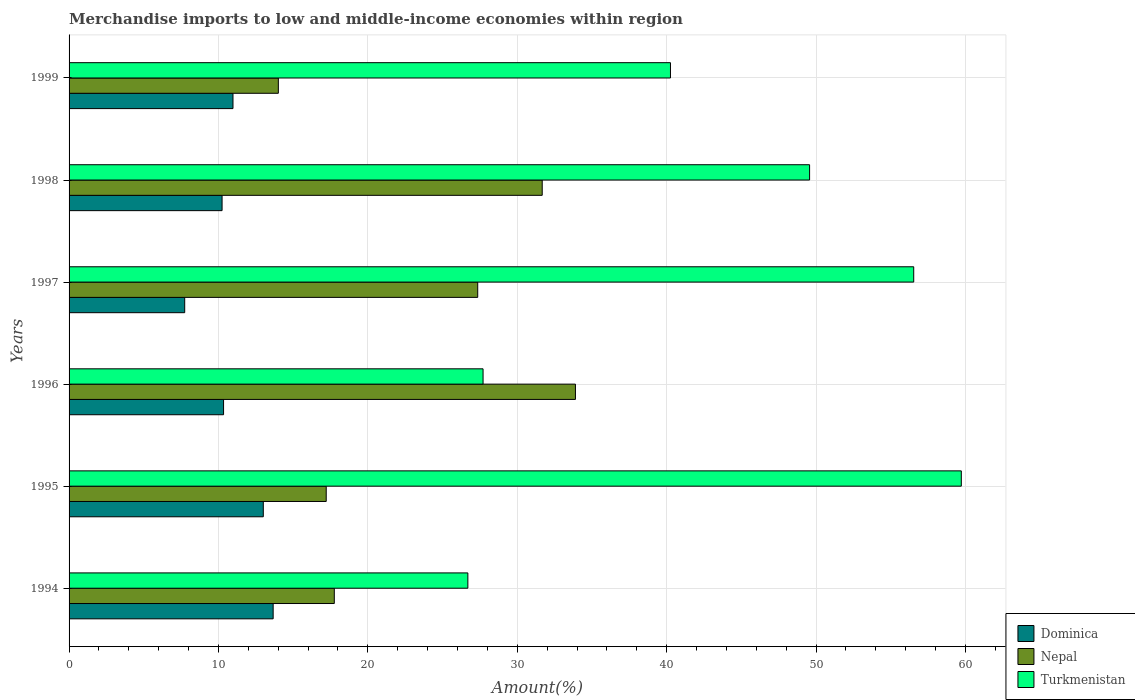How many different coloured bars are there?
Make the answer very short. 3. How many groups of bars are there?
Ensure brevity in your answer.  6. Are the number of bars per tick equal to the number of legend labels?
Your answer should be compact. Yes. How many bars are there on the 4th tick from the top?
Make the answer very short. 3. How many bars are there on the 5th tick from the bottom?
Your response must be concise. 3. What is the label of the 4th group of bars from the top?
Your response must be concise. 1996. What is the percentage of amount earned from merchandise imports in Dominica in 1998?
Give a very brief answer. 10.24. Across all years, what is the maximum percentage of amount earned from merchandise imports in Dominica?
Your answer should be compact. 13.66. Across all years, what is the minimum percentage of amount earned from merchandise imports in Turkmenistan?
Offer a very short reply. 26.69. In which year was the percentage of amount earned from merchandise imports in Turkmenistan maximum?
Your answer should be compact. 1995. In which year was the percentage of amount earned from merchandise imports in Nepal minimum?
Offer a very short reply. 1999. What is the total percentage of amount earned from merchandise imports in Turkmenistan in the graph?
Make the answer very short. 260.49. What is the difference between the percentage of amount earned from merchandise imports in Dominica in 1994 and that in 1998?
Your answer should be compact. 3.42. What is the difference between the percentage of amount earned from merchandise imports in Nepal in 1997 and the percentage of amount earned from merchandise imports in Turkmenistan in 1998?
Your answer should be compact. -22.22. What is the average percentage of amount earned from merchandise imports in Dominica per year?
Your answer should be very brief. 10.99. In the year 1997, what is the difference between the percentage of amount earned from merchandise imports in Dominica and percentage of amount earned from merchandise imports in Nepal?
Provide a succinct answer. -19.61. What is the ratio of the percentage of amount earned from merchandise imports in Dominica in 1995 to that in 1996?
Provide a short and direct response. 1.26. Is the percentage of amount earned from merchandise imports in Dominica in 1997 less than that in 1998?
Ensure brevity in your answer.  Yes. What is the difference between the highest and the second highest percentage of amount earned from merchandise imports in Dominica?
Provide a succinct answer. 0.66. What is the difference between the highest and the lowest percentage of amount earned from merchandise imports in Nepal?
Your response must be concise. 19.89. Is the sum of the percentage of amount earned from merchandise imports in Turkmenistan in 1994 and 1995 greater than the maximum percentage of amount earned from merchandise imports in Nepal across all years?
Offer a terse response. Yes. What does the 2nd bar from the top in 1998 represents?
Give a very brief answer. Nepal. What does the 1st bar from the bottom in 1994 represents?
Your answer should be compact. Dominica. Is it the case that in every year, the sum of the percentage of amount earned from merchandise imports in Turkmenistan and percentage of amount earned from merchandise imports in Dominica is greater than the percentage of amount earned from merchandise imports in Nepal?
Keep it short and to the point. Yes. How many bars are there?
Your response must be concise. 18. Does the graph contain any zero values?
Make the answer very short. No. Where does the legend appear in the graph?
Provide a succinct answer. Bottom right. How many legend labels are there?
Provide a succinct answer. 3. How are the legend labels stacked?
Provide a short and direct response. Vertical. What is the title of the graph?
Make the answer very short. Merchandise imports to low and middle-income economies within region. What is the label or title of the X-axis?
Give a very brief answer. Amount(%). What is the label or title of the Y-axis?
Give a very brief answer. Years. What is the Amount(%) of Dominica in 1994?
Ensure brevity in your answer.  13.66. What is the Amount(%) in Nepal in 1994?
Your response must be concise. 17.75. What is the Amount(%) of Turkmenistan in 1994?
Offer a very short reply. 26.69. What is the Amount(%) of Dominica in 1995?
Make the answer very short. 13. What is the Amount(%) in Nepal in 1995?
Provide a short and direct response. 17.21. What is the Amount(%) of Turkmenistan in 1995?
Your answer should be very brief. 59.72. What is the Amount(%) of Dominica in 1996?
Provide a short and direct response. 10.34. What is the Amount(%) in Nepal in 1996?
Your answer should be compact. 33.89. What is the Amount(%) of Turkmenistan in 1996?
Offer a terse response. 27.71. What is the Amount(%) in Dominica in 1997?
Keep it short and to the point. 7.74. What is the Amount(%) of Nepal in 1997?
Provide a short and direct response. 27.35. What is the Amount(%) of Turkmenistan in 1997?
Provide a short and direct response. 56.54. What is the Amount(%) in Dominica in 1998?
Offer a very short reply. 10.24. What is the Amount(%) of Nepal in 1998?
Your response must be concise. 31.67. What is the Amount(%) in Turkmenistan in 1998?
Give a very brief answer. 49.57. What is the Amount(%) in Dominica in 1999?
Give a very brief answer. 10.97. What is the Amount(%) of Nepal in 1999?
Your response must be concise. 14.01. What is the Amount(%) of Turkmenistan in 1999?
Keep it short and to the point. 40.26. Across all years, what is the maximum Amount(%) in Dominica?
Provide a succinct answer. 13.66. Across all years, what is the maximum Amount(%) of Nepal?
Ensure brevity in your answer.  33.89. Across all years, what is the maximum Amount(%) of Turkmenistan?
Ensure brevity in your answer.  59.72. Across all years, what is the minimum Amount(%) in Dominica?
Your answer should be very brief. 7.74. Across all years, what is the minimum Amount(%) of Nepal?
Your response must be concise. 14.01. Across all years, what is the minimum Amount(%) of Turkmenistan?
Offer a terse response. 26.69. What is the total Amount(%) in Dominica in the graph?
Give a very brief answer. 65.96. What is the total Amount(%) of Nepal in the graph?
Your response must be concise. 141.89. What is the total Amount(%) in Turkmenistan in the graph?
Offer a terse response. 260.49. What is the difference between the Amount(%) of Dominica in 1994 and that in 1995?
Make the answer very short. 0.66. What is the difference between the Amount(%) in Nepal in 1994 and that in 1995?
Make the answer very short. 0.54. What is the difference between the Amount(%) in Turkmenistan in 1994 and that in 1995?
Offer a very short reply. -33.03. What is the difference between the Amount(%) in Dominica in 1994 and that in 1996?
Your response must be concise. 3.32. What is the difference between the Amount(%) in Nepal in 1994 and that in 1996?
Provide a succinct answer. -16.14. What is the difference between the Amount(%) of Turkmenistan in 1994 and that in 1996?
Offer a very short reply. -1.02. What is the difference between the Amount(%) in Dominica in 1994 and that in 1997?
Your answer should be compact. 5.92. What is the difference between the Amount(%) of Nepal in 1994 and that in 1997?
Provide a short and direct response. -9.6. What is the difference between the Amount(%) in Turkmenistan in 1994 and that in 1997?
Ensure brevity in your answer.  -29.84. What is the difference between the Amount(%) in Dominica in 1994 and that in 1998?
Give a very brief answer. 3.42. What is the difference between the Amount(%) in Nepal in 1994 and that in 1998?
Offer a terse response. -13.92. What is the difference between the Amount(%) in Turkmenistan in 1994 and that in 1998?
Make the answer very short. -22.87. What is the difference between the Amount(%) of Dominica in 1994 and that in 1999?
Offer a terse response. 2.69. What is the difference between the Amount(%) in Nepal in 1994 and that in 1999?
Offer a very short reply. 3.75. What is the difference between the Amount(%) in Turkmenistan in 1994 and that in 1999?
Ensure brevity in your answer.  -13.56. What is the difference between the Amount(%) of Dominica in 1995 and that in 1996?
Your answer should be very brief. 2.66. What is the difference between the Amount(%) of Nepal in 1995 and that in 1996?
Your answer should be compact. -16.68. What is the difference between the Amount(%) in Turkmenistan in 1995 and that in 1996?
Provide a succinct answer. 32.01. What is the difference between the Amount(%) of Dominica in 1995 and that in 1997?
Make the answer very short. 5.26. What is the difference between the Amount(%) of Nepal in 1995 and that in 1997?
Your response must be concise. -10.14. What is the difference between the Amount(%) in Turkmenistan in 1995 and that in 1997?
Offer a terse response. 3.19. What is the difference between the Amount(%) in Dominica in 1995 and that in 1998?
Offer a terse response. 2.76. What is the difference between the Amount(%) in Nepal in 1995 and that in 1998?
Give a very brief answer. -14.46. What is the difference between the Amount(%) of Turkmenistan in 1995 and that in 1998?
Your answer should be compact. 10.16. What is the difference between the Amount(%) in Dominica in 1995 and that in 1999?
Make the answer very short. 2.03. What is the difference between the Amount(%) in Nepal in 1995 and that in 1999?
Your answer should be very brief. 3.2. What is the difference between the Amount(%) in Turkmenistan in 1995 and that in 1999?
Offer a terse response. 19.47. What is the difference between the Amount(%) of Dominica in 1996 and that in 1997?
Provide a succinct answer. 2.6. What is the difference between the Amount(%) in Nepal in 1996 and that in 1997?
Make the answer very short. 6.54. What is the difference between the Amount(%) of Turkmenistan in 1996 and that in 1997?
Make the answer very short. -28.83. What is the difference between the Amount(%) in Dominica in 1996 and that in 1998?
Provide a succinct answer. 0.1. What is the difference between the Amount(%) of Nepal in 1996 and that in 1998?
Keep it short and to the point. 2.22. What is the difference between the Amount(%) in Turkmenistan in 1996 and that in 1998?
Your response must be concise. -21.86. What is the difference between the Amount(%) in Dominica in 1996 and that in 1999?
Your answer should be compact. -0.63. What is the difference between the Amount(%) of Nepal in 1996 and that in 1999?
Offer a terse response. 19.89. What is the difference between the Amount(%) in Turkmenistan in 1996 and that in 1999?
Ensure brevity in your answer.  -12.54. What is the difference between the Amount(%) in Dominica in 1997 and that in 1998?
Your response must be concise. -2.5. What is the difference between the Amount(%) of Nepal in 1997 and that in 1998?
Provide a short and direct response. -4.32. What is the difference between the Amount(%) in Turkmenistan in 1997 and that in 1998?
Keep it short and to the point. 6.97. What is the difference between the Amount(%) of Dominica in 1997 and that in 1999?
Your answer should be compact. -3.23. What is the difference between the Amount(%) of Nepal in 1997 and that in 1999?
Your answer should be very brief. 13.34. What is the difference between the Amount(%) in Turkmenistan in 1997 and that in 1999?
Your answer should be very brief. 16.28. What is the difference between the Amount(%) in Dominica in 1998 and that in 1999?
Make the answer very short. -0.73. What is the difference between the Amount(%) of Nepal in 1998 and that in 1999?
Give a very brief answer. 17.66. What is the difference between the Amount(%) in Turkmenistan in 1998 and that in 1999?
Give a very brief answer. 9.31. What is the difference between the Amount(%) in Dominica in 1994 and the Amount(%) in Nepal in 1995?
Provide a short and direct response. -3.55. What is the difference between the Amount(%) of Dominica in 1994 and the Amount(%) of Turkmenistan in 1995?
Your answer should be very brief. -46.06. What is the difference between the Amount(%) of Nepal in 1994 and the Amount(%) of Turkmenistan in 1995?
Provide a succinct answer. -41.97. What is the difference between the Amount(%) of Dominica in 1994 and the Amount(%) of Nepal in 1996?
Provide a short and direct response. -20.23. What is the difference between the Amount(%) in Dominica in 1994 and the Amount(%) in Turkmenistan in 1996?
Offer a very short reply. -14.05. What is the difference between the Amount(%) in Nepal in 1994 and the Amount(%) in Turkmenistan in 1996?
Make the answer very short. -9.96. What is the difference between the Amount(%) in Dominica in 1994 and the Amount(%) in Nepal in 1997?
Your answer should be compact. -13.69. What is the difference between the Amount(%) of Dominica in 1994 and the Amount(%) of Turkmenistan in 1997?
Offer a terse response. -42.88. What is the difference between the Amount(%) in Nepal in 1994 and the Amount(%) in Turkmenistan in 1997?
Your response must be concise. -38.78. What is the difference between the Amount(%) in Dominica in 1994 and the Amount(%) in Nepal in 1998?
Give a very brief answer. -18.01. What is the difference between the Amount(%) of Dominica in 1994 and the Amount(%) of Turkmenistan in 1998?
Offer a terse response. -35.91. What is the difference between the Amount(%) of Nepal in 1994 and the Amount(%) of Turkmenistan in 1998?
Your answer should be compact. -31.81. What is the difference between the Amount(%) in Dominica in 1994 and the Amount(%) in Nepal in 1999?
Your answer should be very brief. -0.35. What is the difference between the Amount(%) in Dominica in 1994 and the Amount(%) in Turkmenistan in 1999?
Keep it short and to the point. -26.59. What is the difference between the Amount(%) of Nepal in 1994 and the Amount(%) of Turkmenistan in 1999?
Your answer should be very brief. -22.5. What is the difference between the Amount(%) in Dominica in 1995 and the Amount(%) in Nepal in 1996?
Your answer should be very brief. -20.89. What is the difference between the Amount(%) of Dominica in 1995 and the Amount(%) of Turkmenistan in 1996?
Offer a very short reply. -14.71. What is the difference between the Amount(%) of Nepal in 1995 and the Amount(%) of Turkmenistan in 1996?
Offer a terse response. -10.5. What is the difference between the Amount(%) in Dominica in 1995 and the Amount(%) in Nepal in 1997?
Make the answer very short. -14.35. What is the difference between the Amount(%) in Dominica in 1995 and the Amount(%) in Turkmenistan in 1997?
Give a very brief answer. -43.54. What is the difference between the Amount(%) in Nepal in 1995 and the Amount(%) in Turkmenistan in 1997?
Provide a short and direct response. -39.32. What is the difference between the Amount(%) of Dominica in 1995 and the Amount(%) of Nepal in 1998?
Ensure brevity in your answer.  -18.67. What is the difference between the Amount(%) of Dominica in 1995 and the Amount(%) of Turkmenistan in 1998?
Offer a terse response. -36.57. What is the difference between the Amount(%) of Nepal in 1995 and the Amount(%) of Turkmenistan in 1998?
Make the answer very short. -32.36. What is the difference between the Amount(%) in Dominica in 1995 and the Amount(%) in Nepal in 1999?
Offer a very short reply. -1.01. What is the difference between the Amount(%) in Dominica in 1995 and the Amount(%) in Turkmenistan in 1999?
Ensure brevity in your answer.  -27.25. What is the difference between the Amount(%) of Nepal in 1995 and the Amount(%) of Turkmenistan in 1999?
Ensure brevity in your answer.  -23.04. What is the difference between the Amount(%) of Dominica in 1996 and the Amount(%) of Nepal in 1997?
Provide a short and direct response. -17.01. What is the difference between the Amount(%) in Dominica in 1996 and the Amount(%) in Turkmenistan in 1997?
Your answer should be very brief. -46.2. What is the difference between the Amount(%) in Nepal in 1996 and the Amount(%) in Turkmenistan in 1997?
Provide a short and direct response. -22.64. What is the difference between the Amount(%) of Dominica in 1996 and the Amount(%) of Nepal in 1998?
Your answer should be very brief. -21.33. What is the difference between the Amount(%) in Dominica in 1996 and the Amount(%) in Turkmenistan in 1998?
Your answer should be very brief. -39.23. What is the difference between the Amount(%) in Nepal in 1996 and the Amount(%) in Turkmenistan in 1998?
Your answer should be compact. -15.67. What is the difference between the Amount(%) of Dominica in 1996 and the Amount(%) of Nepal in 1999?
Give a very brief answer. -3.67. What is the difference between the Amount(%) in Dominica in 1996 and the Amount(%) in Turkmenistan in 1999?
Ensure brevity in your answer.  -29.91. What is the difference between the Amount(%) in Nepal in 1996 and the Amount(%) in Turkmenistan in 1999?
Provide a short and direct response. -6.36. What is the difference between the Amount(%) of Dominica in 1997 and the Amount(%) of Nepal in 1998?
Your response must be concise. -23.93. What is the difference between the Amount(%) of Dominica in 1997 and the Amount(%) of Turkmenistan in 1998?
Your answer should be compact. -41.83. What is the difference between the Amount(%) of Nepal in 1997 and the Amount(%) of Turkmenistan in 1998?
Your response must be concise. -22.22. What is the difference between the Amount(%) in Dominica in 1997 and the Amount(%) in Nepal in 1999?
Keep it short and to the point. -6.27. What is the difference between the Amount(%) in Dominica in 1997 and the Amount(%) in Turkmenistan in 1999?
Offer a very short reply. -32.52. What is the difference between the Amount(%) of Nepal in 1997 and the Amount(%) of Turkmenistan in 1999?
Your answer should be compact. -12.9. What is the difference between the Amount(%) in Dominica in 1998 and the Amount(%) in Nepal in 1999?
Provide a succinct answer. -3.77. What is the difference between the Amount(%) in Dominica in 1998 and the Amount(%) in Turkmenistan in 1999?
Provide a short and direct response. -30.01. What is the difference between the Amount(%) in Nepal in 1998 and the Amount(%) in Turkmenistan in 1999?
Make the answer very short. -8.59. What is the average Amount(%) of Dominica per year?
Offer a very short reply. 10.99. What is the average Amount(%) in Nepal per year?
Provide a short and direct response. 23.65. What is the average Amount(%) in Turkmenistan per year?
Provide a succinct answer. 43.41. In the year 1994, what is the difference between the Amount(%) of Dominica and Amount(%) of Nepal?
Your response must be concise. -4.09. In the year 1994, what is the difference between the Amount(%) of Dominica and Amount(%) of Turkmenistan?
Ensure brevity in your answer.  -13.03. In the year 1994, what is the difference between the Amount(%) in Nepal and Amount(%) in Turkmenistan?
Ensure brevity in your answer.  -8.94. In the year 1995, what is the difference between the Amount(%) of Dominica and Amount(%) of Nepal?
Provide a short and direct response. -4.21. In the year 1995, what is the difference between the Amount(%) of Dominica and Amount(%) of Turkmenistan?
Provide a short and direct response. -46.72. In the year 1995, what is the difference between the Amount(%) in Nepal and Amount(%) in Turkmenistan?
Give a very brief answer. -42.51. In the year 1996, what is the difference between the Amount(%) in Dominica and Amount(%) in Nepal?
Your response must be concise. -23.55. In the year 1996, what is the difference between the Amount(%) in Dominica and Amount(%) in Turkmenistan?
Your answer should be compact. -17.37. In the year 1996, what is the difference between the Amount(%) of Nepal and Amount(%) of Turkmenistan?
Provide a succinct answer. 6.18. In the year 1997, what is the difference between the Amount(%) of Dominica and Amount(%) of Nepal?
Your answer should be very brief. -19.61. In the year 1997, what is the difference between the Amount(%) in Dominica and Amount(%) in Turkmenistan?
Give a very brief answer. -48.8. In the year 1997, what is the difference between the Amount(%) in Nepal and Amount(%) in Turkmenistan?
Your answer should be very brief. -29.18. In the year 1998, what is the difference between the Amount(%) in Dominica and Amount(%) in Nepal?
Ensure brevity in your answer.  -21.43. In the year 1998, what is the difference between the Amount(%) in Dominica and Amount(%) in Turkmenistan?
Ensure brevity in your answer.  -39.33. In the year 1998, what is the difference between the Amount(%) in Nepal and Amount(%) in Turkmenistan?
Ensure brevity in your answer.  -17.9. In the year 1999, what is the difference between the Amount(%) in Dominica and Amount(%) in Nepal?
Your response must be concise. -3.04. In the year 1999, what is the difference between the Amount(%) of Dominica and Amount(%) of Turkmenistan?
Your answer should be very brief. -29.28. In the year 1999, what is the difference between the Amount(%) of Nepal and Amount(%) of Turkmenistan?
Keep it short and to the point. -26.25. What is the ratio of the Amount(%) of Dominica in 1994 to that in 1995?
Provide a short and direct response. 1.05. What is the ratio of the Amount(%) in Nepal in 1994 to that in 1995?
Offer a very short reply. 1.03. What is the ratio of the Amount(%) of Turkmenistan in 1994 to that in 1995?
Your answer should be compact. 0.45. What is the ratio of the Amount(%) of Dominica in 1994 to that in 1996?
Provide a short and direct response. 1.32. What is the ratio of the Amount(%) in Nepal in 1994 to that in 1996?
Your answer should be compact. 0.52. What is the ratio of the Amount(%) of Turkmenistan in 1994 to that in 1996?
Your answer should be very brief. 0.96. What is the ratio of the Amount(%) in Dominica in 1994 to that in 1997?
Make the answer very short. 1.76. What is the ratio of the Amount(%) of Nepal in 1994 to that in 1997?
Your answer should be very brief. 0.65. What is the ratio of the Amount(%) of Turkmenistan in 1994 to that in 1997?
Your answer should be very brief. 0.47. What is the ratio of the Amount(%) in Dominica in 1994 to that in 1998?
Offer a terse response. 1.33. What is the ratio of the Amount(%) of Nepal in 1994 to that in 1998?
Your answer should be very brief. 0.56. What is the ratio of the Amount(%) of Turkmenistan in 1994 to that in 1998?
Ensure brevity in your answer.  0.54. What is the ratio of the Amount(%) in Dominica in 1994 to that in 1999?
Provide a short and direct response. 1.25. What is the ratio of the Amount(%) in Nepal in 1994 to that in 1999?
Keep it short and to the point. 1.27. What is the ratio of the Amount(%) in Turkmenistan in 1994 to that in 1999?
Offer a terse response. 0.66. What is the ratio of the Amount(%) in Dominica in 1995 to that in 1996?
Keep it short and to the point. 1.26. What is the ratio of the Amount(%) in Nepal in 1995 to that in 1996?
Give a very brief answer. 0.51. What is the ratio of the Amount(%) of Turkmenistan in 1995 to that in 1996?
Ensure brevity in your answer.  2.16. What is the ratio of the Amount(%) in Dominica in 1995 to that in 1997?
Give a very brief answer. 1.68. What is the ratio of the Amount(%) of Nepal in 1995 to that in 1997?
Provide a succinct answer. 0.63. What is the ratio of the Amount(%) in Turkmenistan in 1995 to that in 1997?
Offer a very short reply. 1.06. What is the ratio of the Amount(%) of Dominica in 1995 to that in 1998?
Offer a very short reply. 1.27. What is the ratio of the Amount(%) in Nepal in 1995 to that in 1998?
Your answer should be compact. 0.54. What is the ratio of the Amount(%) in Turkmenistan in 1995 to that in 1998?
Make the answer very short. 1.2. What is the ratio of the Amount(%) of Dominica in 1995 to that in 1999?
Offer a very short reply. 1.19. What is the ratio of the Amount(%) in Nepal in 1995 to that in 1999?
Offer a terse response. 1.23. What is the ratio of the Amount(%) of Turkmenistan in 1995 to that in 1999?
Keep it short and to the point. 1.48. What is the ratio of the Amount(%) in Dominica in 1996 to that in 1997?
Your answer should be compact. 1.34. What is the ratio of the Amount(%) in Nepal in 1996 to that in 1997?
Keep it short and to the point. 1.24. What is the ratio of the Amount(%) of Turkmenistan in 1996 to that in 1997?
Ensure brevity in your answer.  0.49. What is the ratio of the Amount(%) of Dominica in 1996 to that in 1998?
Your answer should be very brief. 1.01. What is the ratio of the Amount(%) of Nepal in 1996 to that in 1998?
Ensure brevity in your answer.  1.07. What is the ratio of the Amount(%) of Turkmenistan in 1996 to that in 1998?
Offer a terse response. 0.56. What is the ratio of the Amount(%) of Dominica in 1996 to that in 1999?
Give a very brief answer. 0.94. What is the ratio of the Amount(%) in Nepal in 1996 to that in 1999?
Provide a succinct answer. 2.42. What is the ratio of the Amount(%) of Turkmenistan in 1996 to that in 1999?
Keep it short and to the point. 0.69. What is the ratio of the Amount(%) in Dominica in 1997 to that in 1998?
Ensure brevity in your answer.  0.76. What is the ratio of the Amount(%) in Nepal in 1997 to that in 1998?
Keep it short and to the point. 0.86. What is the ratio of the Amount(%) of Turkmenistan in 1997 to that in 1998?
Provide a short and direct response. 1.14. What is the ratio of the Amount(%) of Dominica in 1997 to that in 1999?
Your answer should be compact. 0.71. What is the ratio of the Amount(%) of Nepal in 1997 to that in 1999?
Keep it short and to the point. 1.95. What is the ratio of the Amount(%) of Turkmenistan in 1997 to that in 1999?
Offer a very short reply. 1.4. What is the ratio of the Amount(%) of Dominica in 1998 to that in 1999?
Provide a short and direct response. 0.93. What is the ratio of the Amount(%) of Nepal in 1998 to that in 1999?
Make the answer very short. 2.26. What is the ratio of the Amount(%) in Turkmenistan in 1998 to that in 1999?
Provide a short and direct response. 1.23. What is the difference between the highest and the second highest Amount(%) in Dominica?
Ensure brevity in your answer.  0.66. What is the difference between the highest and the second highest Amount(%) of Nepal?
Offer a terse response. 2.22. What is the difference between the highest and the second highest Amount(%) of Turkmenistan?
Provide a succinct answer. 3.19. What is the difference between the highest and the lowest Amount(%) of Dominica?
Make the answer very short. 5.92. What is the difference between the highest and the lowest Amount(%) of Nepal?
Make the answer very short. 19.89. What is the difference between the highest and the lowest Amount(%) of Turkmenistan?
Provide a succinct answer. 33.03. 